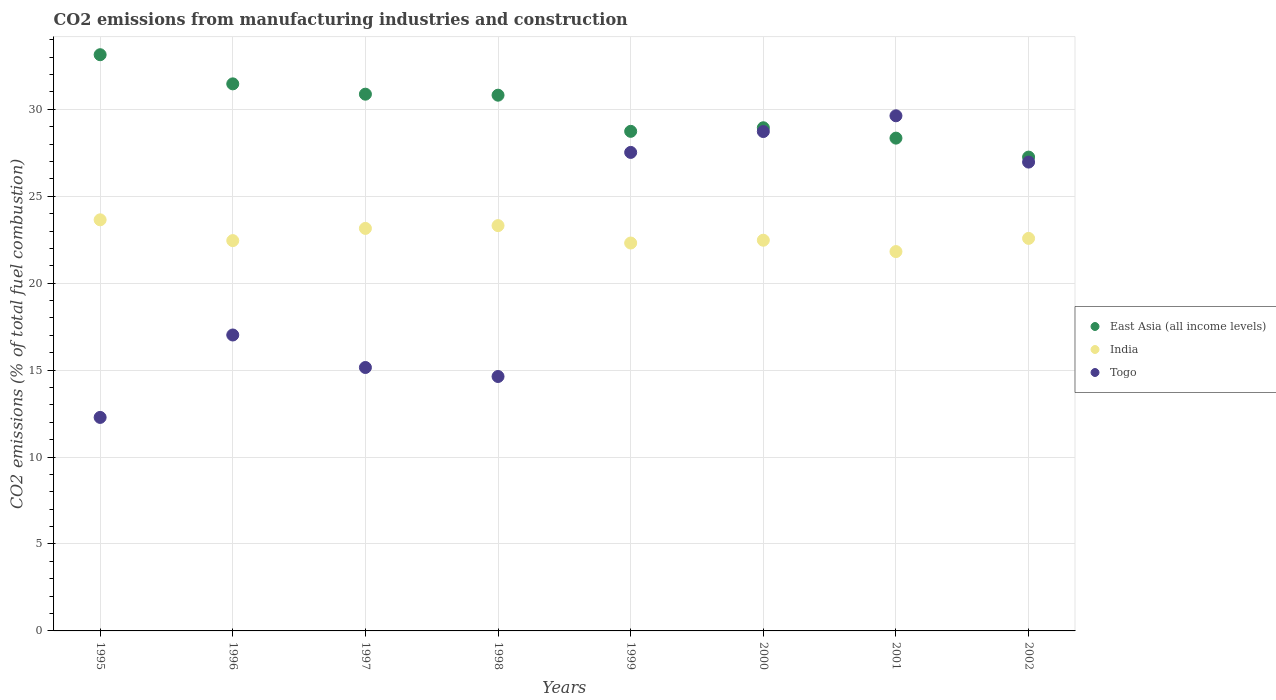How many different coloured dotlines are there?
Ensure brevity in your answer.  3. Is the number of dotlines equal to the number of legend labels?
Offer a very short reply. Yes. What is the amount of CO2 emitted in East Asia (all income levels) in 2001?
Keep it short and to the point. 28.34. Across all years, what is the maximum amount of CO2 emitted in India?
Ensure brevity in your answer.  23.65. Across all years, what is the minimum amount of CO2 emitted in India?
Offer a very short reply. 21.82. In which year was the amount of CO2 emitted in India minimum?
Make the answer very short. 2001. What is the total amount of CO2 emitted in Togo in the graph?
Keep it short and to the point. 171.93. What is the difference between the amount of CO2 emitted in India in 1995 and that in 1997?
Your response must be concise. 0.49. What is the difference between the amount of CO2 emitted in Togo in 1999 and the amount of CO2 emitted in East Asia (all income levels) in 2000?
Your answer should be compact. -1.42. What is the average amount of CO2 emitted in East Asia (all income levels) per year?
Provide a short and direct response. 29.95. In the year 1998, what is the difference between the amount of CO2 emitted in East Asia (all income levels) and amount of CO2 emitted in India?
Provide a succinct answer. 7.5. What is the ratio of the amount of CO2 emitted in India in 1995 to that in 1998?
Your answer should be very brief. 1.01. Is the amount of CO2 emitted in East Asia (all income levels) in 1998 less than that in 2001?
Keep it short and to the point. No. What is the difference between the highest and the second highest amount of CO2 emitted in Togo?
Offer a terse response. 0.91. What is the difference between the highest and the lowest amount of CO2 emitted in Togo?
Keep it short and to the point. 17.35. Is the sum of the amount of CO2 emitted in East Asia (all income levels) in 1997 and 2001 greater than the maximum amount of CO2 emitted in Togo across all years?
Provide a short and direct response. Yes. Is it the case that in every year, the sum of the amount of CO2 emitted in East Asia (all income levels) and amount of CO2 emitted in Togo  is greater than the amount of CO2 emitted in India?
Offer a very short reply. Yes. Does the amount of CO2 emitted in Togo monotonically increase over the years?
Your response must be concise. No. Is the amount of CO2 emitted in Togo strictly greater than the amount of CO2 emitted in East Asia (all income levels) over the years?
Offer a terse response. No. What is the difference between two consecutive major ticks on the Y-axis?
Provide a short and direct response. 5. How many legend labels are there?
Offer a very short reply. 3. What is the title of the graph?
Give a very brief answer. CO2 emissions from manufacturing industries and construction. Does "Dominican Republic" appear as one of the legend labels in the graph?
Your answer should be very brief. No. What is the label or title of the X-axis?
Your answer should be very brief. Years. What is the label or title of the Y-axis?
Give a very brief answer. CO2 emissions (% of total fuel combustion). What is the CO2 emissions (% of total fuel combustion) of East Asia (all income levels) in 1995?
Offer a terse response. 33.14. What is the CO2 emissions (% of total fuel combustion) in India in 1995?
Provide a short and direct response. 23.65. What is the CO2 emissions (% of total fuel combustion) in Togo in 1995?
Give a very brief answer. 12.28. What is the CO2 emissions (% of total fuel combustion) of East Asia (all income levels) in 1996?
Make the answer very short. 31.47. What is the CO2 emissions (% of total fuel combustion) in India in 1996?
Provide a short and direct response. 22.45. What is the CO2 emissions (% of total fuel combustion) in Togo in 1996?
Keep it short and to the point. 17.02. What is the CO2 emissions (% of total fuel combustion) of East Asia (all income levels) in 1997?
Your answer should be compact. 30.87. What is the CO2 emissions (% of total fuel combustion) in India in 1997?
Provide a succinct answer. 23.15. What is the CO2 emissions (% of total fuel combustion) of Togo in 1997?
Make the answer very short. 15.15. What is the CO2 emissions (% of total fuel combustion) in East Asia (all income levels) in 1998?
Ensure brevity in your answer.  30.81. What is the CO2 emissions (% of total fuel combustion) of India in 1998?
Offer a terse response. 23.31. What is the CO2 emissions (% of total fuel combustion) of Togo in 1998?
Your response must be concise. 14.63. What is the CO2 emissions (% of total fuel combustion) of East Asia (all income levels) in 1999?
Offer a terse response. 28.73. What is the CO2 emissions (% of total fuel combustion) of India in 1999?
Your response must be concise. 22.31. What is the CO2 emissions (% of total fuel combustion) in Togo in 1999?
Offer a terse response. 27.52. What is the CO2 emissions (% of total fuel combustion) of East Asia (all income levels) in 2000?
Offer a very short reply. 28.94. What is the CO2 emissions (% of total fuel combustion) in India in 2000?
Offer a terse response. 22.47. What is the CO2 emissions (% of total fuel combustion) in Togo in 2000?
Your answer should be compact. 28.72. What is the CO2 emissions (% of total fuel combustion) of East Asia (all income levels) in 2001?
Give a very brief answer. 28.34. What is the CO2 emissions (% of total fuel combustion) in India in 2001?
Provide a succinct answer. 21.82. What is the CO2 emissions (% of total fuel combustion) in Togo in 2001?
Make the answer very short. 29.63. What is the CO2 emissions (% of total fuel combustion) of East Asia (all income levels) in 2002?
Provide a succinct answer. 27.25. What is the CO2 emissions (% of total fuel combustion) in India in 2002?
Offer a very short reply. 22.58. What is the CO2 emissions (% of total fuel combustion) in Togo in 2002?
Provide a succinct answer. 26.97. Across all years, what is the maximum CO2 emissions (% of total fuel combustion) of East Asia (all income levels)?
Offer a very short reply. 33.14. Across all years, what is the maximum CO2 emissions (% of total fuel combustion) in India?
Offer a terse response. 23.65. Across all years, what is the maximum CO2 emissions (% of total fuel combustion) of Togo?
Your answer should be very brief. 29.63. Across all years, what is the minimum CO2 emissions (% of total fuel combustion) of East Asia (all income levels)?
Your response must be concise. 27.25. Across all years, what is the minimum CO2 emissions (% of total fuel combustion) in India?
Your answer should be very brief. 21.82. Across all years, what is the minimum CO2 emissions (% of total fuel combustion) in Togo?
Offer a terse response. 12.28. What is the total CO2 emissions (% of total fuel combustion) of East Asia (all income levels) in the graph?
Your answer should be very brief. 239.57. What is the total CO2 emissions (% of total fuel combustion) in India in the graph?
Provide a succinct answer. 181.74. What is the total CO2 emissions (% of total fuel combustion) in Togo in the graph?
Keep it short and to the point. 171.93. What is the difference between the CO2 emissions (% of total fuel combustion) in East Asia (all income levels) in 1995 and that in 1996?
Your answer should be compact. 1.68. What is the difference between the CO2 emissions (% of total fuel combustion) of India in 1995 and that in 1996?
Your answer should be compact. 1.2. What is the difference between the CO2 emissions (% of total fuel combustion) in Togo in 1995 and that in 1996?
Provide a succinct answer. -4.74. What is the difference between the CO2 emissions (% of total fuel combustion) in East Asia (all income levels) in 1995 and that in 1997?
Ensure brevity in your answer.  2.27. What is the difference between the CO2 emissions (% of total fuel combustion) in India in 1995 and that in 1997?
Provide a short and direct response. 0.49. What is the difference between the CO2 emissions (% of total fuel combustion) in Togo in 1995 and that in 1997?
Provide a succinct answer. -2.87. What is the difference between the CO2 emissions (% of total fuel combustion) of East Asia (all income levels) in 1995 and that in 1998?
Provide a succinct answer. 2.33. What is the difference between the CO2 emissions (% of total fuel combustion) of India in 1995 and that in 1998?
Provide a succinct answer. 0.33. What is the difference between the CO2 emissions (% of total fuel combustion) in Togo in 1995 and that in 1998?
Offer a terse response. -2.35. What is the difference between the CO2 emissions (% of total fuel combustion) in East Asia (all income levels) in 1995 and that in 1999?
Make the answer very short. 4.41. What is the difference between the CO2 emissions (% of total fuel combustion) of India in 1995 and that in 1999?
Keep it short and to the point. 1.34. What is the difference between the CO2 emissions (% of total fuel combustion) in Togo in 1995 and that in 1999?
Ensure brevity in your answer.  -15.24. What is the difference between the CO2 emissions (% of total fuel combustion) in East Asia (all income levels) in 1995 and that in 2000?
Offer a very short reply. 4.2. What is the difference between the CO2 emissions (% of total fuel combustion) in India in 1995 and that in 2000?
Make the answer very short. 1.17. What is the difference between the CO2 emissions (% of total fuel combustion) in Togo in 1995 and that in 2000?
Keep it short and to the point. -16.44. What is the difference between the CO2 emissions (% of total fuel combustion) of East Asia (all income levels) in 1995 and that in 2001?
Ensure brevity in your answer.  4.8. What is the difference between the CO2 emissions (% of total fuel combustion) in India in 1995 and that in 2001?
Ensure brevity in your answer.  1.83. What is the difference between the CO2 emissions (% of total fuel combustion) in Togo in 1995 and that in 2001?
Make the answer very short. -17.35. What is the difference between the CO2 emissions (% of total fuel combustion) of East Asia (all income levels) in 1995 and that in 2002?
Make the answer very short. 5.89. What is the difference between the CO2 emissions (% of total fuel combustion) of India in 1995 and that in 2002?
Offer a terse response. 1.07. What is the difference between the CO2 emissions (% of total fuel combustion) in Togo in 1995 and that in 2002?
Provide a short and direct response. -14.69. What is the difference between the CO2 emissions (% of total fuel combustion) in East Asia (all income levels) in 1996 and that in 1997?
Give a very brief answer. 0.59. What is the difference between the CO2 emissions (% of total fuel combustion) in India in 1996 and that in 1997?
Give a very brief answer. -0.7. What is the difference between the CO2 emissions (% of total fuel combustion) of Togo in 1996 and that in 1997?
Ensure brevity in your answer.  1.87. What is the difference between the CO2 emissions (% of total fuel combustion) in East Asia (all income levels) in 1996 and that in 1998?
Your answer should be very brief. 0.65. What is the difference between the CO2 emissions (% of total fuel combustion) in India in 1996 and that in 1998?
Your answer should be very brief. -0.86. What is the difference between the CO2 emissions (% of total fuel combustion) of Togo in 1996 and that in 1998?
Your response must be concise. 2.39. What is the difference between the CO2 emissions (% of total fuel combustion) in East Asia (all income levels) in 1996 and that in 1999?
Ensure brevity in your answer.  2.73. What is the difference between the CO2 emissions (% of total fuel combustion) in India in 1996 and that in 1999?
Provide a short and direct response. 0.14. What is the difference between the CO2 emissions (% of total fuel combustion) in Togo in 1996 and that in 1999?
Provide a short and direct response. -10.5. What is the difference between the CO2 emissions (% of total fuel combustion) in East Asia (all income levels) in 1996 and that in 2000?
Ensure brevity in your answer.  2.53. What is the difference between the CO2 emissions (% of total fuel combustion) in India in 1996 and that in 2000?
Keep it short and to the point. -0.02. What is the difference between the CO2 emissions (% of total fuel combustion) of Togo in 1996 and that in 2000?
Ensure brevity in your answer.  -11.7. What is the difference between the CO2 emissions (% of total fuel combustion) of East Asia (all income levels) in 1996 and that in 2001?
Your answer should be compact. 3.12. What is the difference between the CO2 emissions (% of total fuel combustion) in India in 1996 and that in 2001?
Provide a succinct answer. 0.63. What is the difference between the CO2 emissions (% of total fuel combustion) in Togo in 1996 and that in 2001?
Offer a very short reply. -12.61. What is the difference between the CO2 emissions (% of total fuel combustion) of East Asia (all income levels) in 1996 and that in 2002?
Ensure brevity in your answer.  4.21. What is the difference between the CO2 emissions (% of total fuel combustion) in India in 1996 and that in 2002?
Provide a succinct answer. -0.13. What is the difference between the CO2 emissions (% of total fuel combustion) in Togo in 1996 and that in 2002?
Offer a very short reply. -9.95. What is the difference between the CO2 emissions (% of total fuel combustion) in East Asia (all income levels) in 1997 and that in 1998?
Make the answer very short. 0.06. What is the difference between the CO2 emissions (% of total fuel combustion) of India in 1997 and that in 1998?
Offer a very short reply. -0.16. What is the difference between the CO2 emissions (% of total fuel combustion) in Togo in 1997 and that in 1998?
Your response must be concise. 0.52. What is the difference between the CO2 emissions (% of total fuel combustion) in East Asia (all income levels) in 1997 and that in 1999?
Provide a succinct answer. 2.14. What is the difference between the CO2 emissions (% of total fuel combustion) in India in 1997 and that in 1999?
Provide a short and direct response. 0.84. What is the difference between the CO2 emissions (% of total fuel combustion) in Togo in 1997 and that in 1999?
Provide a short and direct response. -12.37. What is the difference between the CO2 emissions (% of total fuel combustion) in East Asia (all income levels) in 1997 and that in 2000?
Keep it short and to the point. 1.93. What is the difference between the CO2 emissions (% of total fuel combustion) in India in 1997 and that in 2000?
Offer a terse response. 0.68. What is the difference between the CO2 emissions (% of total fuel combustion) of Togo in 1997 and that in 2000?
Provide a succinct answer. -13.57. What is the difference between the CO2 emissions (% of total fuel combustion) in East Asia (all income levels) in 1997 and that in 2001?
Your response must be concise. 2.53. What is the difference between the CO2 emissions (% of total fuel combustion) of Togo in 1997 and that in 2001?
Offer a very short reply. -14.48. What is the difference between the CO2 emissions (% of total fuel combustion) in East Asia (all income levels) in 1997 and that in 2002?
Give a very brief answer. 3.62. What is the difference between the CO2 emissions (% of total fuel combustion) in India in 1997 and that in 2002?
Your response must be concise. 0.57. What is the difference between the CO2 emissions (% of total fuel combustion) of Togo in 1997 and that in 2002?
Your answer should be very brief. -11.81. What is the difference between the CO2 emissions (% of total fuel combustion) of East Asia (all income levels) in 1998 and that in 1999?
Provide a succinct answer. 2.08. What is the difference between the CO2 emissions (% of total fuel combustion) of Togo in 1998 and that in 1999?
Your answer should be compact. -12.89. What is the difference between the CO2 emissions (% of total fuel combustion) in East Asia (all income levels) in 1998 and that in 2000?
Give a very brief answer. 1.87. What is the difference between the CO2 emissions (% of total fuel combustion) in India in 1998 and that in 2000?
Ensure brevity in your answer.  0.84. What is the difference between the CO2 emissions (% of total fuel combustion) in Togo in 1998 and that in 2000?
Your response must be concise. -14.09. What is the difference between the CO2 emissions (% of total fuel combustion) in East Asia (all income levels) in 1998 and that in 2001?
Ensure brevity in your answer.  2.47. What is the difference between the CO2 emissions (% of total fuel combustion) in India in 1998 and that in 2001?
Offer a terse response. 1.49. What is the difference between the CO2 emissions (% of total fuel combustion) in Togo in 1998 and that in 2001?
Provide a succinct answer. -15. What is the difference between the CO2 emissions (% of total fuel combustion) in East Asia (all income levels) in 1998 and that in 2002?
Your response must be concise. 3.56. What is the difference between the CO2 emissions (% of total fuel combustion) in India in 1998 and that in 2002?
Keep it short and to the point. 0.73. What is the difference between the CO2 emissions (% of total fuel combustion) in Togo in 1998 and that in 2002?
Give a very brief answer. -12.33. What is the difference between the CO2 emissions (% of total fuel combustion) of East Asia (all income levels) in 1999 and that in 2000?
Ensure brevity in your answer.  -0.21. What is the difference between the CO2 emissions (% of total fuel combustion) of India in 1999 and that in 2000?
Make the answer very short. -0.16. What is the difference between the CO2 emissions (% of total fuel combustion) of Togo in 1999 and that in 2000?
Keep it short and to the point. -1.2. What is the difference between the CO2 emissions (% of total fuel combustion) of East Asia (all income levels) in 1999 and that in 2001?
Give a very brief answer. 0.39. What is the difference between the CO2 emissions (% of total fuel combustion) in India in 1999 and that in 2001?
Give a very brief answer. 0.49. What is the difference between the CO2 emissions (% of total fuel combustion) in Togo in 1999 and that in 2001?
Give a very brief answer. -2.11. What is the difference between the CO2 emissions (% of total fuel combustion) of East Asia (all income levels) in 1999 and that in 2002?
Your answer should be compact. 1.48. What is the difference between the CO2 emissions (% of total fuel combustion) of India in 1999 and that in 2002?
Ensure brevity in your answer.  -0.27. What is the difference between the CO2 emissions (% of total fuel combustion) of Togo in 1999 and that in 2002?
Offer a very short reply. 0.56. What is the difference between the CO2 emissions (% of total fuel combustion) in East Asia (all income levels) in 2000 and that in 2001?
Your response must be concise. 0.6. What is the difference between the CO2 emissions (% of total fuel combustion) in India in 2000 and that in 2001?
Make the answer very short. 0.65. What is the difference between the CO2 emissions (% of total fuel combustion) in Togo in 2000 and that in 2001?
Make the answer very short. -0.91. What is the difference between the CO2 emissions (% of total fuel combustion) in East Asia (all income levels) in 2000 and that in 2002?
Ensure brevity in your answer.  1.69. What is the difference between the CO2 emissions (% of total fuel combustion) in India in 2000 and that in 2002?
Your response must be concise. -0.11. What is the difference between the CO2 emissions (% of total fuel combustion) of Togo in 2000 and that in 2002?
Your answer should be compact. 1.76. What is the difference between the CO2 emissions (% of total fuel combustion) of East Asia (all income levels) in 2001 and that in 2002?
Provide a short and direct response. 1.09. What is the difference between the CO2 emissions (% of total fuel combustion) in India in 2001 and that in 2002?
Your answer should be compact. -0.76. What is the difference between the CO2 emissions (% of total fuel combustion) in Togo in 2001 and that in 2002?
Offer a very short reply. 2.66. What is the difference between the CO2 emissions (% of total fuel combustion) of East Asia (all income levels) in 1995 and the CO2 emissions (% of total fuel combustion) of India in 1996?
Your answer should be compact. 10.69. What is the difference between the CO2 emissions (% of total fuel combustion) in East Asia (all income levels) in 1995 and the CO2 emissions (% of total fuel combustion) in Togo in 1996?
Your answer should be very brief. 16.12. What is the difference between the CO2 emissions (% of total fuel combustion) in India in 1995 and the CO2 emissions (% of total fuel combustion) in Togo in 1996?
Offer a terse response. 6.62. What is the difference between the CO2 emissions (% of total fuel combustion) in East Asia (all income levels) in 1995 and the CO2 emissions (% of total fuel combustion) in India in 1997?
Provide a short and direct response. 9.99. What is the difference between the CO2 emissions (% of total fuel combustion) of East Asia (all income levels) in 1995 and the CO2 emissions (% of total fuel combustion) of Togo in 1997?
Ensure brevity in your answer.  17.99. What is the difference between the CO2 emissions (% of total fuel combustion) in India in 1995 and the CO2 emissions (% of total fuel combustion) in Togo in 1997?
Make the answer very short. 8.49. What is the difference between the CO2 emissions (% of total fuel combustion) of East Asia (all income levels) in 1995 and the CO2 emissions (% of total fuel combustion) of India in 1998?
Provide a succinct answer. 9.83. What is the difference between the CO2 emissions (% of total fuel combustion) of East Asia (all income levels) in 1995 and the CO2 emissions (% of total fuel combustion) of Togo in 1998?
Ensure brevity in your answer.  18.51. What is the difference between the CO2 emissions (% of total fuel combustion) of India in 1995 and the CO2 emissions (% of total fuel combustion) of Togo in 1998?
Offer a very short reply. 9.01. What is the difference between the CO2 emissions (% of total fuel combustion) in East Asia (all income levels) in 1995 and the CO2 emissions (% of total fuel combustion) in India in 1999?
Give a very brief answer. 10.83. What is the difference between the CO2 emissions (% of total fuel combustion) in East Asia (all income levels) in 1995 and the CO2 emissions (% of total fuel combustion) in Togo in 1999?
Provide a short and direct response. 5.62. What is the difference between the CO2 emissions (% of total fuel combustion) of India in 1995 and the CO2 emissions (% of total fuel combustion) of Togo in 1999?
Your answer should be compact. -3.88. What is the difference between the CO2 emissions (% of total fuel combustion) of East Asia (all income levels) in 1995 and the CO2 emissions (% of total fuel combustion) of India in 2000?
Give a very brief answer. 10.67. What is the difference between the CO2 emissions (% of total fuel combustion) of East Asia (all income levels) in 1995 and the CO2 emissions (% of total fuel combustion) of Togo in 2000?
Your answer should be very brief. 4.42. What is the difference between the CO2 emissions (% of total fuel combustion) of India in 1995 and the CO2 emissions (% of total fuel combustion) of Togo in 2000?
Your answer should be compact. -5.08. What is the difference between the CO2 emissions (% of total fuel combustion) of East Asia (all income levels) in 1995 and the CO2 emissions (% of total fuel combustion) of India in 2001?
Your response must be concise. 11.32. What is the difference between the CO2 emissions (% of total fuel combustion) of East Asia (all income levels) in 1995 and the CO2 emissions (% of total fuel combustion) of Togo in 2001?
Your response must be concise. 3.51. What is the difference between the CO2 emissions (% of total fuel combustion) in India in 1995 and the CO2 emissions (% of total fuel combustion) in Togo in 2001?
Your answer should be compact. -5.98. What is the difference between the CO2 emissions (% of total fuel combustion) of East Asia (all income levels) in 1995 and the CO2 emissions (% of total fuel combustion) of India in 2002?
Provide a short and direct response. 10.56. What is the difference between the CO2 emissions (% of total fuel combustion) of East Asia (all income levels) in 1995 and the CO2 emissions (% of total fuel combustion) of Togo in 2002?
Give a very brief answer. 6.18. What is the difference between the CO2 emissions (% of total fuel combustion) of India in 1995 and the CO2 emissions (% of total fuel combustion) of Togo in 2002?
Provide a succinct answer. -3.32. What is the difference between the CO2 emissions (% of total fuel combustion) of East Asia (all income levels) in 1996 and the CO2 emissions (% of total fuel combustion) of India in 1997?
Provide a short and direct response. 8.31. What is the difference between the CO2 emissions (% of total fuel combustion) in East Asia (all income levels) in 1996 and the CO2 emissions (% of total fuel combustion) in Togo in 1997?
Make the answer very short. 16.31. What is the difference between the CO2 emissions (% of total fuel combustion) of India in 1996 and the CO2 emissions (% of total fuel combustion) of Togo in 1997?
Give a very brief answer. 7.3. What is the difference between the CO2 emissions (% of total fuel combustion) of East Asia (all income levels) in 1996 and the CO2 emissions (% of total fuel combustion) of India in 1998?
Keep it short and to the point. 8.15. What is the difference between the CO2 emissions (% of total fuel combustion) of East Asia (all income levels) in 1996 and the CO2 emissions (% of total fuel combustion) of Togo in 1998?
Keep it short and to the point. 16.83. What is the difference between the CO2 emissions (% of total fuel combustion) of India in 1996 and the CO2 emissions (% of total fuel combustion) of Togo in 1998?
Your response must be concise. 7.82. What is the difference between the CO2 emissions (% of total fuel combustion) of East Asia (all income levels) in 1996 and the CO2 emissions (% of total fuel combustion) of India in 1999?
Your answer should be compact. 9.16. What is the difference between the CO2 emissions (% of total fuel combustion) in East Asia (all income levels) in 1996 and the CO2 emissions (% of total fuel combustion) in Togo in 1999?
Provide a short and direct response. 3.94. What is the difference between the CO2 emissions (% of total fuel combustion) of India in 1996 and the CO2 emissions (% of total fuel combustion) of Togo in 1999?
Provide a short and direct response. -5.07. What is the difference between the CO2 emissions (% of total fuel combustion) of East Asia (all income levels) in 1996 and the CO2 emissions (% of total fuel combustion) of India in 2000?
Your answer should be compact. 8.99. What is the difference between the CO2 emissions (% of total fuel combustion) of East Asia (all income levels) in 1996 and the CO2 emissions (% of total fuel combustion) of Togo in 2000?
Keep it short and to the point. 2.74. What is the difference between the CO2 emissions (% of total fuel combustion) in India in 1996 and the CO2 emissions (% of total fuel combustion) in Togo in 2000?
Ensure brevity in your answer.  -6.27. What is the difference between the CO2 emissions (% of total fuel combustion) in East Asia (all income levels) in 1996 and the CO2 emissions (% of total fuel combustion) in India in 2001?
Keep it short and to the point. 9.65. What is the difference between the CO2 emissions (% of total fuel combustion) of East Asia (all income levels) in 1996 and the CO2 emissions (% of total fuel combustion) of Togo in 2001?
Provide a short and direct response. 1.84. What is the difference between the CO2 emissions (% of total fuel combustion) in India in 1996 and the CO2 emissions (% of total fuel combustion) in Togo in 2001?
Keep it short and to the point. -7.18. What is the difference between the CO2 emissions (% of total fuel combustion) in East Asia (all income levels) in 1996 and the CO2 emissions (% of total fuel combustion) in India in 2002?
Your response must be concise. 8.89. What is the difference between the CO2 emissions (% of total fuel combustion) in East Asia (all income levels) in 1996 and the CO2 emissions (% of total fuel combustion) in Togo in 2002?
Offer a very short reply. 4.5. What is the difference between the CO2 emissions (% of total fuel combustion) of India in 1996 and the CO2 emissions (% of total fuel combustion) of Togo in 2002?
Provide a succinct answer. -4.52. What is the difference between the CO2 emissions (% of total fuel combustion) in East Asia (all income levels) in 1997 and the CO2 emissions (% of total fuel combustion) in India in 1998?
Provide a succinct answer. 7.56. What is the difference between the CO2 emissions (% of total fuel combustion) in East Asia (all income levels) in 1997 and the CO2 emissions (% of total fuel combustion) in Togo in 1998?
Make the answer very short. 16.24. What is the difference between the CO2 emissions (% of total fuel combustion) in India in 1997 and the CO2 emissions (% of total fuel combustion) in Togo in 1998?
Keep it short and to the point. 8.52. What is the difference between the CO2 emissions (% of total fuel combustion) of East Asia (all income levels) in 1997 and the CO2 emissions (% of total fuel combustion) of India in 1999?
Offer a terse response. 8.56. What is the difference between the CO2 emissions (% of total fuel combustion) of East Asia (all income levels) in 1997 and the CO2 emissions (% of total fuel combustion) of Togo in 1999?
Offer a terse response. 3.35. What is the difference between the CO2 emissions (% of total fuel combustion) in India in 1997 and the CO2 emissions (% of total fuel combustion) in Togo in 1999?
Offer a very short reply. -4.37. What is the difference between the CO2 emissions (% of total fuel combustion) of East Asia (all income levels) in 1997 and the CO2 emissions (% of total fuel combustion) of India in 2000?
Offer a very short reply. 8.4. What is the difference between the CO2 emissions (% of total fuel combustion) of East Asia (all income levels) in 1997 and the CO2 emissions (% of total fuel combustion) of Togo in 2000?
Give a very brief answer. 2.15. What is the difference between the CO2 emissions (% of total fuel combustion) in India in 1997 and the CO2 emissions (% of total fuel combustion) in Togo in 2000?
Offer a very short reply. -5.57. What is the difference between the CO2 emissions (% of total fuel combustion) of East Asia (all income levels) in 1997 and the CO2 emissions (% of total fuel combustion) of India in 2001?
Your answer should be very brief. 9.05. What is the difference between the CO2 emissions (% of total fuel combustion) in East Asia (all income levels) in 1997 and the CO2 emissions (% of total fuel combustion) in Togo in 2001?
Offer a very short reply. 1.24. What is the difference between the CO2 emissions (% of total fuel combustion) in India in 1997 and the CO2 emissions (% of total fuel combustion) in Togo in 2001?
Give a very brief answer. -6.48. What is the difference between the CO2 emissions (% of total fuel combustion) in East Asia (all income levels) in 1997 and the CO2 emissions (% of total fuel combustion) in India in 2002?
Give a very brief answer. 8.29. What is the difference between the CO2 emissions (% of total fuel combustion) of East Asia (all income levels) in 1997 and the CO2 emissions (% of total fuel combustion) of Togo in 2002?
Provide a succinct answer. 3.91. What is the difference between the CO2 emissions (% of total fuel combustion) of India in 1997 and the CO2 emissions (% of total fuel combustion) of Togo in 2002?
Make the answer very short. -3.81. What is the difference between the CO2 emissions (% of total fuel combustion) of East Asia (all income levels) in 1998 and the CO2 emissions (% of total fuel combustion) of India in 1999?
Give a very brief answer. 8.5. What is the difference between the CO2 emissions (% of total fuel combustion) in East Asia (all income levels) in 1998 and the CO2 emissions (% of total fuel combustion) in Togo in 1999?
Make the answer very short. 3.29. What is the difference between the CO2 emissions (% of total fuel combustion) in India in 1998 and the CO2 emissions (% of total fuel combustion) in Togo in 1999?
Keep it short and to the point. -4.21. What is the difference between the CO2 emissions (% of total fuel combustion) in East Asia (all income levels) in 1998 and the CO2 emissions (% of total fuel combustion) in India in 2000?
Keep it short and to the point. 8.34. What is the difference between the CO2 emissions (% of total fuel combustion) of East Asia (all income levels) in 1998 and the CO2 emissions (% of total fuel combustion) of Togo in 2000?
Offer a very short reply. 2.09. What is the difference between the CO2 emissions (% of total fuel combustion) of India in 1998 and the CO2 emissions (% of total fuel combustion) of Togo in 2000?
Your response must be concise. -5.41. What is the difference between the CO2 emissions (% of total fuel combustion) of East Asia (all income levels) in 1998 and the CO2 emissions (% of total fuel combustion) of India in 2001?
Provide a succinct answer. 9. What is the difference between the CO2 emissions (% of total fuel combustion) in East Asia (all income levels) in 1998 and the CO2 emissions (% of total fuel combustion) in Togo in 2001?
Your response must be concise. 1.18. What is the difference between the CO2 emissions (% of total fuel combustion) of India in 1998 and the CO2 emissions (% of total fuel combustion) of Togo in 2001?
Provide a succinct answer. -6.32. What is the difference between the CO2 emissions (% of total fuel combustion) in East Asia (all income levels) in 1998 and the CO2 emissions (% of total fuel combustion) in India in 2002?
Make the answer very short. 8.24. What is the difference between the CO2 emissions (% of total fuel combustion) of East Asia (all income levels) in 1998 and the CO2 emissions (% of total fuel combustion) of Togo in 2002?
Offer a very short reply. 3.85. What is the difference between the CO2 emissions (% of total fuel combustion) of India in 1998 and the CO2 emissions (% of total fuel combustion) of Togo in 2002?
Your answer should be very brief. -3.65. What is the difference between the CO2 emissions (% of total fuel combustion) of East Asia (all income levels) in 1999 and the CO2 emissions (% of total fuel combustion) of India in 2000?
Give a very brief answer. 6.26. What is the difference between the CO2 emissions (% of total fuel combustion) in East Asia (all income levels) in 1999 and the CO2 emissions (% of total fuel combustion) in Togo in 2000?
Give a very brief answer. 0.01. What is the difference between the CO2 emissions (% of total fuel combustion) of India in 1999 and the CO2 emissions (% of total fuel combustion) of Togo in 2000?
Keep it short and to the point. -6.41. What is the difference between the CO2 emissions (% of total fuel combustion) of East Asia (all income levels) in 1999 and the CO2 emissions (% of total fuel combustion) of India in 2001?
Provide a short and direct response. 6.92. What is the difference between the CO2 emissions (% of total fuel combustion) in East Asia (all income levels) in 1999 and the CO2 emissions (% of total fuel combustion) in Togo in 2001?
Give a very brief answer. -0.89. What is the difference between the CO2 emissions (% of total fuel combustion) in India in 1999 and the CO2 emissions (% of total fuel combustion) in Togo in 2001?
Offer a terse response. -7.32. What is the difference between the CO2 emissions (% of total fuel combustion) in East Asia (all income levels) in 1999 and the CO2 emissions (% of total fuel combustion) in India in 2002?
Make the answer very short. 6.16. What is the difference between the CO2 emissions (% of total fuel combustion) of East Asia (all income levels) in 1999 and the CO2 emissions (% of total fuel combustion) of Togo in 2002?
Offer a terse response. 1.77. What is the difference between the CO2 emissions (% of total fuel combustion) in India in 1999 and the CO2 emissions (% of total fuel combustion) in Togo in 2002?
Give a very brief answer. -4.66. What is the difference between the CO2 emissions (% of total fuel combustion) in East Asia (all income levels) in 2000 and the CO2 emissions (% of total fuel combustion) in India in 2001?
Your response must be concise. 7.12. What is the difference between the CO2 emissions (% of total fuel combustion) in East Asia (all income levels) in 2000 and the CO2 emissions (% of total fuel combustion) in Togo in 2001?
Ensure brevity in your answer.  -0.69. What is the difference between the CO2 emissions (% of total fuel combustion) in India in 2000 and the CO2 emissions (% of total fuel combustion) in Togo in 2001?
Provide a short and direct response. -7.16. What is the difference between the CO2 emissions (% of total fuel combustion) in East Asia (all income levels) in 2000 and the CO2 emissions (% of total fuel combustion) in India in 2002?
Make the answer very short. 6.36. What is the difference between the CO2 emissions (% of total fuel combustion) of East Asia (all income levels) in 2000 and the CO2 emissions (% of total fuel combustion) of Togo in 2002?
Ensure brevity in your answer.  1.97. What is the difference between the CO2 emissions (% of total fuel combustion) of India in 2000 and the CO2 emissions (% of total fuel combustion) of Togo in 2002?
Ensure brevity in your answer.  -4.49. What is the difference between the CO2 emissions (% of total fuel combustion) of East Asia (all income levels) in 2001 and the CO2 emissions (% of total fuel combustion) of India in 2002?
Your answer should be compact. 5.77. What is the difference between the CO2 emissions (% of total fuel combustion) in East Asia (all income levels) in 2001 and the CO2 emissions (% of total fuel combustion) in Togo in 2002?
Provide a succinct answer. 1.38. What is the difference between the CO2 emissions (% of total fuel combustion) in India in 2001 and the CO2 emissions (% of total fuel combustion) in Togo in 2002?
Ensure brevity in your answer.  -5.15. What is the average CO2 emissions (% of total fuel combustion) in East Asia (all income levels) per year?
Make the answer very short. 29.95. What is the average CO2 emissions (% of total fuel combustion) in India per year?
Your response must be concise. 22.72. What is the average CO2 emissions (% of total fuel combustion) of Togo per year?
Provide a short and direct response. 21.49. In the year 1995, what is the difference between the CO2 emissions (% of total fuel combustion) of East Asia (all income levels) and CO2 emissions (% of total fuel combustion) of India?
Provide a short and direct response. 9.5. In the year 1995, what is the difference between the CO2 emissions (% of total fuel combustion) of East Asia (all income levels) and CO2 emissions (% of total fuel combustion) of Togo?
Your answer should be very brief. 20.86. In the year 1995, what is the difference between the CO2 emissions (% of total fuel combustion) of India and CO2 emissions (% of total fuel combustion) of Togo?
Give a very brief answer. 11.37. In the year 1996, what is the difference between the CO2 emissions (% of total fuel combustion) of East Asia (all income levels) and CO2 emissions (% of total fuel combustion) of India?
Provide a short and direct response. 9.02. In the year 1996, what is the difference between the CO2 emissions (% of total fuel combustion) of East Asia (all income levels) and CO2 emissions (% of total fuel combustion) of Togo?
Make the answer very short. 14.44. In the year 1996, what is the difference between the CO2 emissions (% of total fuel combustion) of India and CO2 emissions (% of total fuel combustion) of Togo?
Ensure brevity in your answer.  5.43. In the year 1997, what is the difference between the CO2 emissions (% of total fuel combustion) of East Asia (all income levels) and CO2 emissions (% of total fuel combustion) of India?
Keep it short and to the point. 7.72. In the year 1997, what is the difference between the CO2 emissions (% of total fuel combustion) in East Asia (all income levels) and CO2 emissions (% of total fuel combustion) in Togo?
Offer a terse response. 15.72. In the year 1997, what is the difference between the CO2 emissions (% of total fuel combustion) of India and CO2 emissions (% of total fuel combustion) of Togo?
Offer a terse response. 8. In the year 1998, what is the difference between the CO2 emissions (% of total fuel combustion) of East Asia (all income levels) and CO2 emissions (% of total fuel combustion) of India?
Give a very brief answer. 7.5. In the year 1998, what is the difference between the CO2 emissions (% of total fuel combustion) of East Asia (all income levels) and CO2 emissions (% of total fuel combustion) of Togo?
Make the answer very short. 16.18. In the year 1998, what is the difference between the CO2 emissions (% of total fuel combustion) of India and CO2 emissions (% of total fuel combustion) of Togo?
Give a very brief answer. 8.68. In the year 1999, what is the difference between the CO2 emissions (% of total fuel combustion) in East Asia (all income levels) and CO2 emissions (% of total fuel combustion) in India?
Offer a terse response. 6.42. In the year 1999, what is the difference between the CO2 emissions (% of total fuel combustion) of East Asia (all income levels) and CO2 emissions (% of total fuel combustion) of Togo?
Offer a very short reply. 1.21. In the year 1999, what is the difference between the CO2 emissions (% of total fuel combustion) of India and CO2 emissions (% of total fuel combustion) of Togo?
Keep it short and to the point. -5.21. In the year 2000, what is the difference between the CO2 emissions (% of total fuel combustion) in East Asia (all income levels) and CO2 emissions (% of total fuel combustion) in India?
Your response must be concise. 6.47. In the year 2000, what is the difference between the CO2 emissions (% of total fuel combustion) in East Asia (all income levels) and CO2 emissions (% of total fuel combustion) in Togo?
Provide a succinct answer. 0.22. In the year 2000, what is the difference between the CO2 emissions (% of total fuel combustion) in India and CO2 emissions (% of total fuel combustion) in Togo?
Ensure brevity in your answer.  -6.25. In the year 2001, what is the difference between the CO2 emissions (% of total fuel combustion) in East Asia (all income levels) and CO2 emissions (% of total fuel combustion) in India?
Provide a short and direct response. 6.53. In the year 2001, what is the difference between the CO2 emissions (% of total fuel combustion) in East Asia (all income levels) and CO2 emissions (% of total fuel combustion) in Togo?
Make the answer very short. -1.29. In the year 2001, what is the difference between the CO2 emissions (% of total fuel combustion) of India and CO2 emissions (% of total fuel combustion) of Togo?
Give a very brief answer. -7.81. In the year 2002, what is the difference between the CO2 emissions (% of total fuel combustion) of East Asia (all income levels) and CO2 emissions (% of total fuel combustion) of India?
Your answer should be very brief. 4.68. In the year 2002, what is the difference between the CO2 emissions (% of total fuel combustion) of East Asia (all income levels) and CO2 emissions (% of total fuel combustion) of Togo?
Provide a succinct answer. 0.29. In the year 2002, what is the difference between the CO2 emissions (% of total fuel combustion) in India and CO2 emissions (% of total fuel combustion) in Togo?
Ensure brevity in your answer.  -4.39. What is the ratio of the CO2 emissions (% of total fuel combustion) in East Asia (all income levels) in 1995 to that in 1996?
Offer a terse response. 1.05. What is the ratio of the CO2 emissions (% of total fuel combustion) in India in 1995 to that in 1996?
Make the answer very short. 1.05. What is the ratio of the CO2 emissions (% of total fuel combustion) of Togo in 1995 to that in 1996?
Make the answer very short. 0.72. What is the ratio of the CO2 emissions (% of total fuel combustion) of East Asia (all income levels) in 1995 to that in 1997?
Give a very brief answer. 1.07. What is the ratio of the CO2 emissions (% of total fuel combustion) of India in 1995 to that in 1997?
Keep it short and to the point. 1.02. What is the ratio of the CO2 emissions (% of total fuel combustion) of Togo in 1995 to that in 1997?
Keep it short and to the point. 0.81. What is the ratio of the CO2 emissions (% of total fuel combustion) in East Asia (all income levels) in 1995 to that in 1998?
Your answer should be compact. 1.08. What is the ratio of the CO2 emissions (% of total fuel combustion) in India in 1995 to that in 1998?
Your answer should be very brief. 1.01. What is the ratio of the CO2 emissions (% of total fuel combustion) of Togo in 1995 to that in 1998?
Provide a succinct answer. 0.84. What is the ratio of the CO2 emissions (% of total fuel combustion) in East Asia (all income levels) in 1995 to that in 1999?
Offer a terse response. 1.15. What is the ratio of the CO2 emissions (% of total fuel combustion) in India in 1995 to that in 1999?
Offer a very short reply. 1.06. What is the ratio of the CO2 emissions (% of total fuel combustion) in Togo in 1995 to that in 1999?
Your answer should be very brief. 0.45. What is the ratio of the CO2 emissions (% of total fuel combustion) of East Asia (all income levels) in 1995 to that in 2000?
Ensure brevity in your answer.  1.15. What is the ratio of the CO2 emissions (% of total fuel combustion) of India in 1995 to that in 2000?
Provide a short and direct response. 1.05. What is the ratio of the CO2 emissions (% of total fuel combustion) of Togo in 1995 to that in 2000?
Provide a succinct answer. 0.43. What is the ratio of the CO2 emissions (% of total fuel combustion) of East Asia (all income levels) in 1995 to that in 2001?
Offer a terse response. 1.17. What is the ratio of the CO2 emissions (% of total fuel combustion) in India in 1995 to that in 2001?
Keep it short and to the point. 1.08. What is the ratio of the CO2 emissions (% of total fuel combustion) in Togo in 1995 to that in 2001?
Your response must be concise. 0.41. What is the ratio of the CO2 emissions (% of total fuel combustion) in East Asia (all income levels) in 1995 to that in 2002?
Offer a terse response. 1.22. What is the ratio of the CO2 emissions (% of total fuel combustion) in India in 1995 to that in 2002?
Offer a very short reply. 1.05. What is the ratio of the CO2 emissions (% of total fuel combustion) in Togo in 1995 to that in 2002?
Provide a succinct answer. 0.46. What is the ratio of the CO2 emissions (% of total fuel combustion) of East Asia (all income levels) in 1996 to that in 1997?
Make the answer very short. 1.02. What is the ratio of the CO2 emissions (% of total fuel combustion) in India in 1996 to that in 1997?
Ensure brevity in your answer.  0.97. What is the ratio of the CO2 emissions (% of total fuel combustion) of Togo in 1996 to that in 1997?
Ensure brevity in your answer.  1.12. What is the ratio of the CO2 emissions (% of total fuel combustion) in East Asia (all income levels) in 1996 to that in 1998?
Ensure brevity in your answer.  1.02. What is the ratio of the CO2 emissions (% of total fuel combustion) in Togo in 1996 to that in 1998?
Offer a terse response. 1.16. What is the ratio of the CO2 emissions (% of total fuel combustion) of East Asia (all income levels) in 1996 to that in 1999?
Your answer should be compact. 1.09. What is the ratio of the CO2 emissions (% of total fuel combustion) in Togo in 1996 to that in 1999?
Provide a succinct answer. 0.62. What is the ratio of the CO2 emissions (% of total fuel combustion) of East Asia (all income levels) in 1996 to that in 2000?
Your answer should be very brief. 1.09. What is the ratio of the CO2 emissions (% of total fuel combustion) of India in 1996 to that in 2000?
Give a very brief answer. 1. What is the ratio of the CO2 emissions (% of total fuel combustion) in Togo in 1996 to that in 2000?
Your answer should be compact. 0.59. What is the ratio of the CO2 emissions (% of total fuel combustion) in East Asia (all income levels) in 1996 to that in 2001?
Make the answer very short. 1.11. What is the ratio of the CO2 emissions (% of total fuel combustion) of India in 1996 to that in 2001?
Keep it short and to the point. 1.03. What is the ratio of the CO2 emissions (% of total fuel combustion) of Togo in 1996 to that in 2001?
Keep it short and to the point. 0.57. What is the ratio of the CO2 emissions (% of total fuel combustion) of East Asia (all income levels) in 1996 to that in 2002?
Offer a terse response. 1.15. What is the ratio of the CO2 emissions (% of total fuel combustion) in India in 1996 to that in 2002?
Give a very brief answer. 0.99. What is the ratio of the CO2 emissions (% of total fuel combustion) in Togo in 1996 to that in 2002?
Your answer should be compact. 0.63. What is the ratio of the CO2 emissions (% of total fuel combustion) in East Asia (all income levels) in 1997 to that in 1998?
Your response must be concise. 1. What is the ratio of the CO2 emissions (% of total fuel combustion) in India in 1997 to that in 1998?
Ensure brevity in your answer.  0.99. What is the ratio of the CO2 emissions (% of total fuel combustion) of Togo in 1997 to that in 1998?
Offer a very short reply. 1.04. What is the ratio of the CO2 emissions (% of total fuel combustion) in East Asia (all income levels) in 1997 to that in 1999?
Offer a terse response. 1.07. What is the ratio of the CO2 emissions (% of total fuel combustion) of India in 1997 to that in 1999?
Provide a short and direct response. 1.04. What is the ratio of the CO2 emissions (% of total fuel combustion) of Togo in 1997 to that in 1999?
Provide a short and direct response. 0.55. What is the ratio of the CO2 emissions (% of total fuel combustion) in East Asia (all income levels) in 1997 to that in 2000?
Provide a succinct answer. 1.07. What is the ratio of the CO2 emissions (% of total fuel combustion) in India in 1997 to that in 2000?
Provide a short and direct response. 1.03. What is the ratio of the CO2 emissions (% of total fuel combustion) of Togo in 1997 to that in 2000?
Provide a succinct answer. 0.53. What is the ratio of the CO2 emissions (% of total fuel combustion) of East Asia (all income levels) in 1997 to that in 2001?
Provide a succinct answer. 1.09. What is the ratio of the CO2 emissions (% of total fuel combustion) of India in 1997 to that in 2001?
Make the answer very short. 1.06. What is the ratio of the CO2 emissions (% of total fuel combustion) in Togo in 1997 to that in 2001?
Offer a very short reply. 0.51. What is the ratio of the CO2 emissions (% of total fuel combustion) of East Asia (all income levels) in 1997 to that in 2002?
Offer a terse response. 1.13. What is the ratio of the CO2 emissions (% of total fuel combustion) in India in 1997 to that in 2002?
Offer a very short reply. 1.03. What is the ratio of the CO2 emissions (% of total fuel combustion) of Togo in 1997 to that in 2002?
Provide a short and direct response. 0.56. What is the ratio of the CO2 emissions (% of total fuel combustion) of East Asia (all income levels) in 1998 to that in 1999?
Give a very brief answer. 1.07. What is the ratio of the CO2 emissions (% of total fuel combustion) in India in 1998 to that in 1999?
Make the answer very short. 1.04. What is the ratio of the CO2 emissions (% of total fuel combustion) of Togo in 1998 to that in 1999?
Provide a succinct answer. 0.53. What is the ratio of the CO2 emissions (% of total fuel combustion) in East Asia (all income levels) in 1998 to that in 2000?
Your answer should be compact. 1.06. What is the ratio of the CO2 emissions (% of total fuel combustion) of India in 1998 to that in 2000?
Offer a terse response. 1.04. What is the ratio of the CO2 emissions (% of total fuel combustion) in Togo in 1998 to that in 2000?
Provide a short and direct response. 0.51. What is the ratio of the CO2 emissions (% of total fuel combustion) of East Asia (all income levels) in 1998 to that in 2001?
Your answer should be compact. 1.09. What is the ratio of the CO2 emissions (% of total fuel combustion) of India in 1998 to that in 2001?
Make the answer very short. 1.07. What is the ratio of the CO2 emissions (% of total fuel combustion) of Togo in 1998 to that in 2001?
Offer a very short reply. 0.49. What is the ratio of the CO2 emissions (% of total fuel combustion) of East Asia (all income levels) in 1998 to that in 2002?
Provide a short and direct response. 1.13. What is the ratio of the CO2 emissions (% of total fuel combustion) of India in 1998 to that in 2002?
Offer a very short reply. 1.03. What is the ratio of the CO2 emissions (% of total fuel combustion) in Togo in 1998 to that in 2002?
Offer a very short reply. 0.54. What is the ratio of the CO2 emissions (% of total fuel combustion) in India in 1999 to that in 2000?
Offer a very short reply. 0.99. What is the ratio of the CO2 emissions (% of total fuel combustion) of Togo in 1999 to that in 2000?
Provide a succinct answer. 0.96. What is the ratio of the CO2 emissions (% of total fuel combustion) in East Asia (all income levels) in 1999 to that in 2001?
Offer a terse response. 1.01. What is the ratio of the CO2 emissions (% of total fuel combustion) of India in 1999 to that in 2001?
Offer a terse response. 1.02. What is the ratio of the CO2 emissions (% of total fuel combustion) in Togo in 1999 to that in 2001?
Ensure brevity in your answer.  0.93. What is the ratio of the CO2 emissions (% of total fuel combustion) in East Asia (all income levels) in 1999 to that in 2002?
Ensure brevity in your answer.  1.05. What is the ratio of the CO2 emissions (% of total fuel combustion) of India in 1999 to that in 2002?
Offer a very short reply. 0.99. What is the ratio of the CO2 emissions (% of total fuel combustion) of Togo in 1999 to that in 2002?
Your answer should be compact. 1.02. What is the ratio of the CO2 emissions (% of total fuel combustion) of India in 2000 to that in 2001?
Offer a very short reply. 1.03. What is the ratio of the CO2 emissions (% of total fuel combustion) in Togo in 2000 to that in 2001?
Give a very brief answer. 0.97. What is the ratio of the CO2 emissions (% of total fuel combustion) in East Asia (all income levels) in 2000 to that in 2002?
Offer a very short reply. 1.06. What is the ratio of the CO2 emissions (% of total fuel combustion) in India in 2000 to that in 2002?
Offer a very short reply. 1. What is the ratio of the CO2 emissions (% of total fuel combustion) of Togo in 2000 to that in 2002?
Give a very brief answer. 1.07. What is the ratio of the CO2 emissions (% of total fuel combustion) in India in 2001 to that in 2002?
Keep it short and to the point. 0.97. What is the ratio of the CO2 emissions (% of total fuel combustion) of Togo in 2001 to that in 2002?
Provide a succinct answer. 1.1. What is the difference between the highest and the second highest CO2 emissions (% of total fuel combustion) of East Asia (all income levels)?
Provide a succinct answer. 1.68. What is the difference between the highest and the second highest CO2 emissions (% of total fuel combustion) in India?
Provide a short and direct response. 0.33. What is the difference between the highest and the second highest CO2 emissions (% of total fuel combustion) of Togo?
Ensure brevity in your answer.  0.91. What is the difference between the highest and the lowest CO2 emissions (% of total fuel combustion) of East Asia (all income levels)?
Your response must be concise. 5.89. What is the difference between the highest and the lowest CO2 emissions (% of total fuel combustion) of India?
Offer a terse response. 1.83. What is the difference between the highest and the lowest CO2 emissions (% of total fuel combustion) in Togo?
Your answer should be compact. 17.35. 